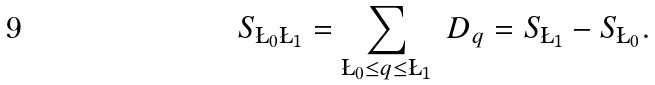Convert formula to latex. <formula><loc_0><loc_0><loc_500><loc_500>S _ { \L _ { 0 } \L _ { 1 } } = \sum _ { \L _ { 0 } \leq q \leq \L _ { 1 } } \ D _ { q } = S _ { \L _ { 1 } } - S _ { \L _ { 0 } } .</formula> 